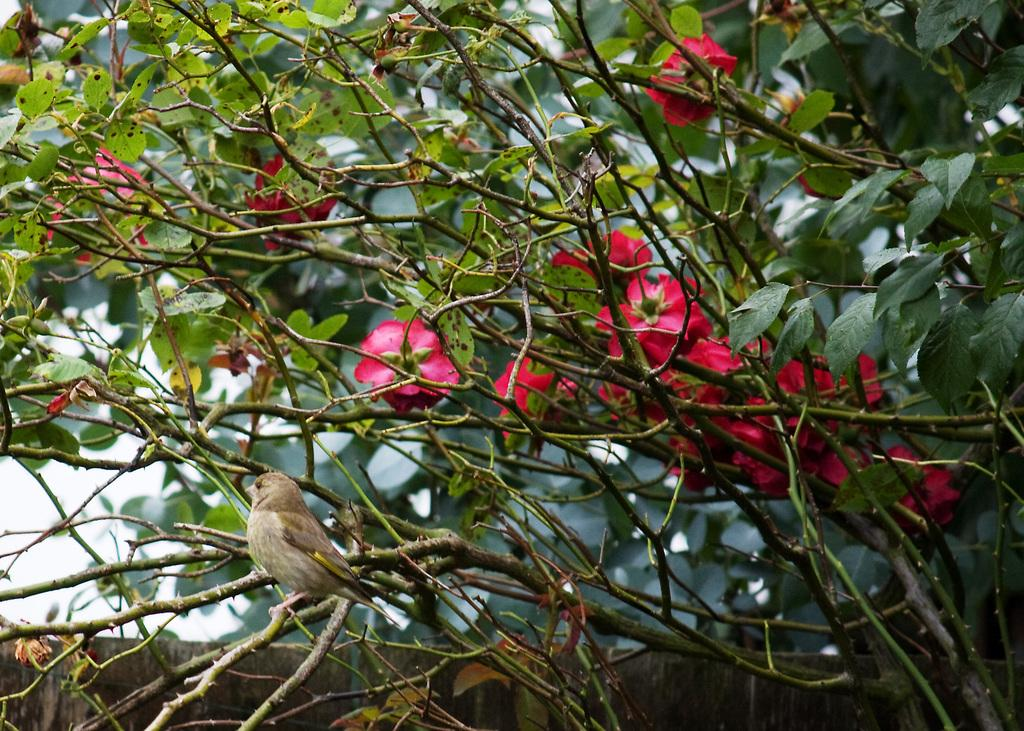What type of vegetation can be seen in the image? There are trees in the image. What color are the flowers visible in the image? There are red color flowers in the image. What type of animal can be seen in the image? There is a bird in the image. What structure is present in the image? There is a wall in the image. What is visible at the top of the image? The sky is visible at the top of the image. What type of watch is the bird wearing in the image? There is no watch present in the image, and the bird is not wearing any accessories. What is the purpose of the air in the image? The air is not an object or subject in the image, and therefore it does not have a purpose within the context of the image. 